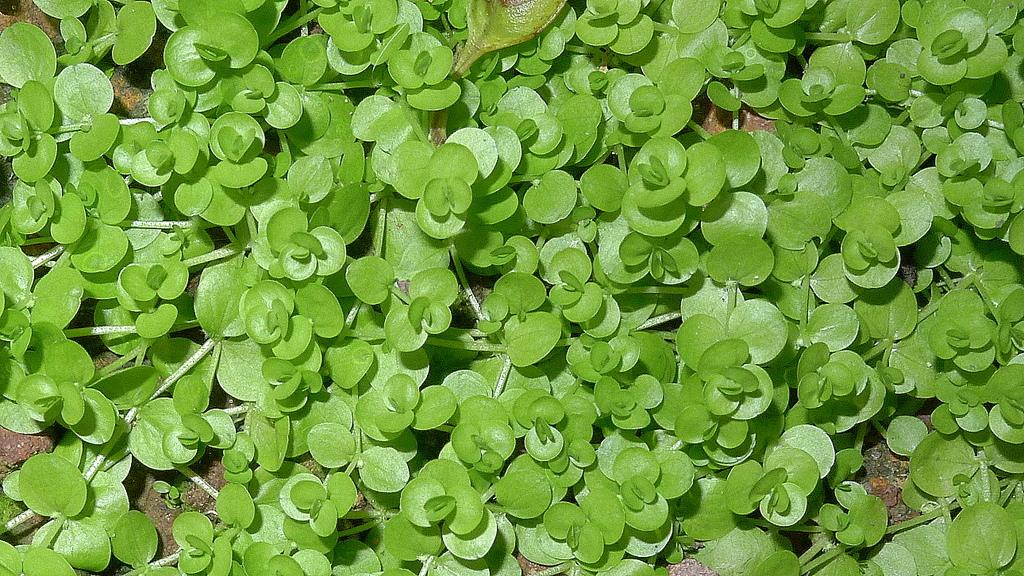What type of living organisms can be seen in the image? Plants can be seen in the image. What is visible at the bottom of the image? There is mud visible at the bottom of the image. Where is the toothbrush located in the image? There is no toothbrush present in the image. What type of footwear is visible in the image? There is no shoe present in the image. 